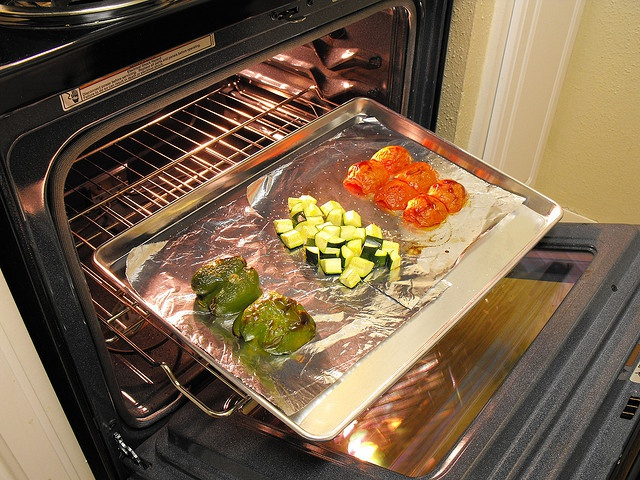Describe the objects in this image and their specific colors. I can see a oven in black, gray, olive, and tan tones in this image. 